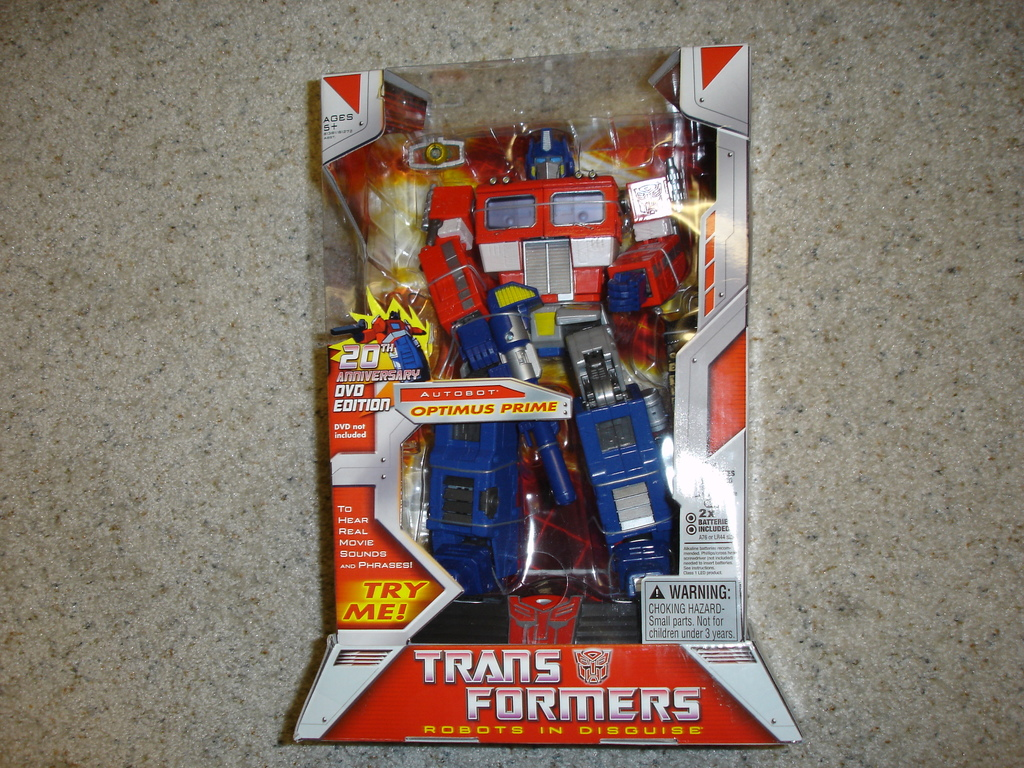Explain the warning label seen on the packaging. The warning label on the packaging indicates a choking hazard, specifying that the toy contains parts not suitable for children under 3 years old. This is a standard safety precaution to prevent accidents involving small parts that could be swallowed or inhaled by young children. 